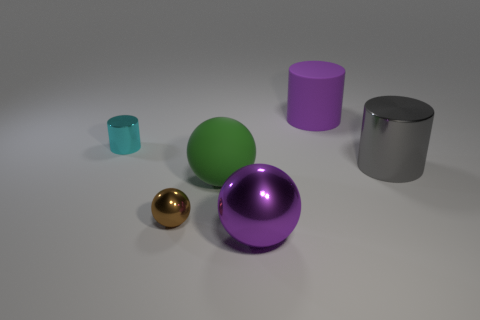Is the material of the large thing that is right of the purple rubber cylinder the same as the green thing?
Your answer should be very brief. No. Is the color of the rubber cylinder the same as the large metallic sphere?
Give a very brief answer. Yes. Is there anything else that is the same color as the big matte cylinder?
Offer a terse response. Yes. What number of things are tiny cylinders or things that are in front of the big gray cylinder?
Provide a succinct answer. 4. What number of other things are there of the same size as the matte sphere?
Provide a short and direct response. 3. Do the big purple object that is in front of the big purple rubber object and the large cylinder that is in front of the cyan metallic thing have the same material?
Give a very brief answer. Yes. There is a tiny metallic ball; how many big metallic objects are behind it?
Offer a terse response. 1. What number of cyan things are either tiny rubber things or large objects?
Your answer should be very brief. 0. There is a purple sphere that is the same size as the gray shiny object; what is its material?
Keep it short and to the point. Metal. There is a large object that is both to the right of the purple metal ball and in front of the rubber cylinder; what is its shape?
Your response must be concise. Cylinder. 